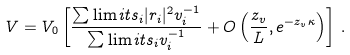<formula> <loc_0><loc_0><loc_500><loc_500>V = V _ { 0 } \left [ \frac { \sum \lim i t s _ { i } | r _ { i } | ^ { 2 } v _ { i } ^ { - 1 } } { \sum \lim i t s _ { i } v _ { i } ^ { - 1 } } + O \left ( \frac { z _ { v } } { L } , e ^ { - z _ { v } \kappa } \right ) \right ] \, .</formula> 